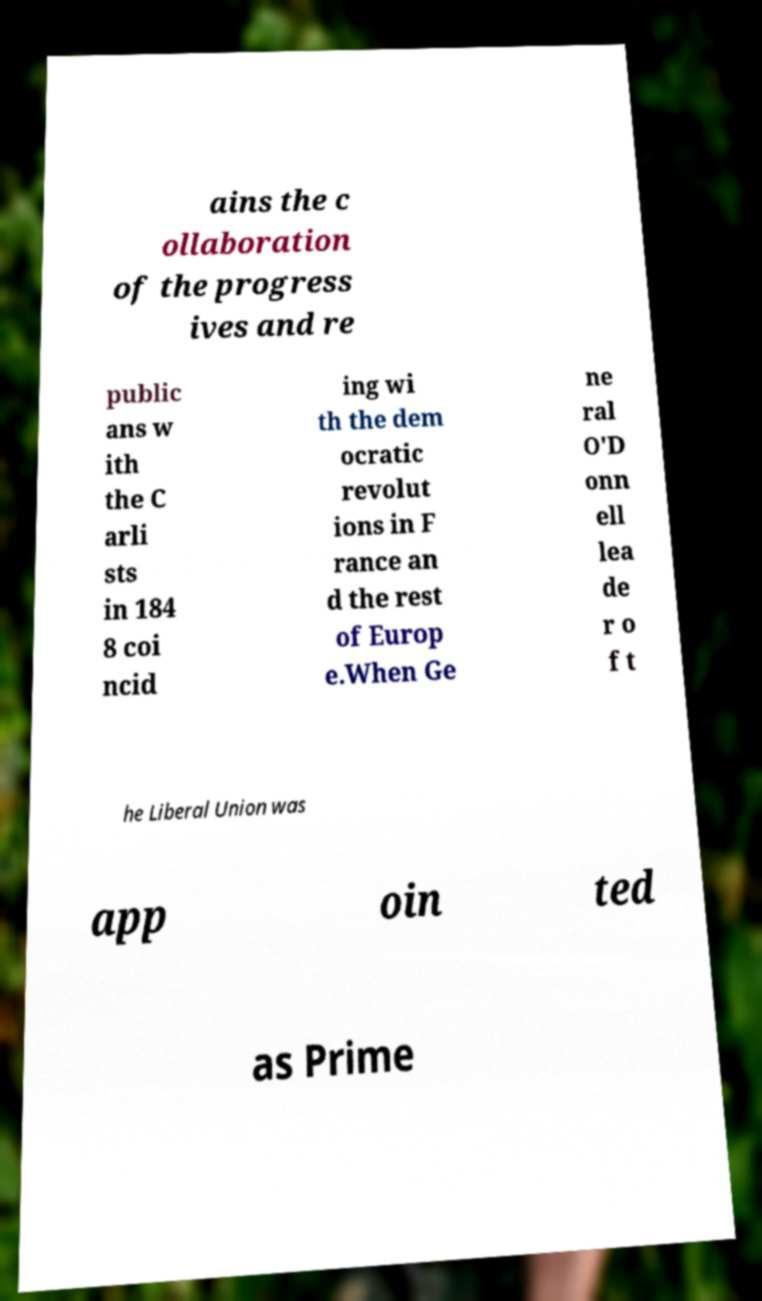For documentation purposes, I need the text within this image transcribed. Could you provide that? ains the c ollaboration of the progress ives and re public ans w ith the C arli sts in 184 8 coi ncid ing wi th the dem ocratic revolut ions in F rance an d the rest of Europ e.When Ge ne ral O'D onn ell lea de r o f t he Liberal Union was app oin ted as Prime 